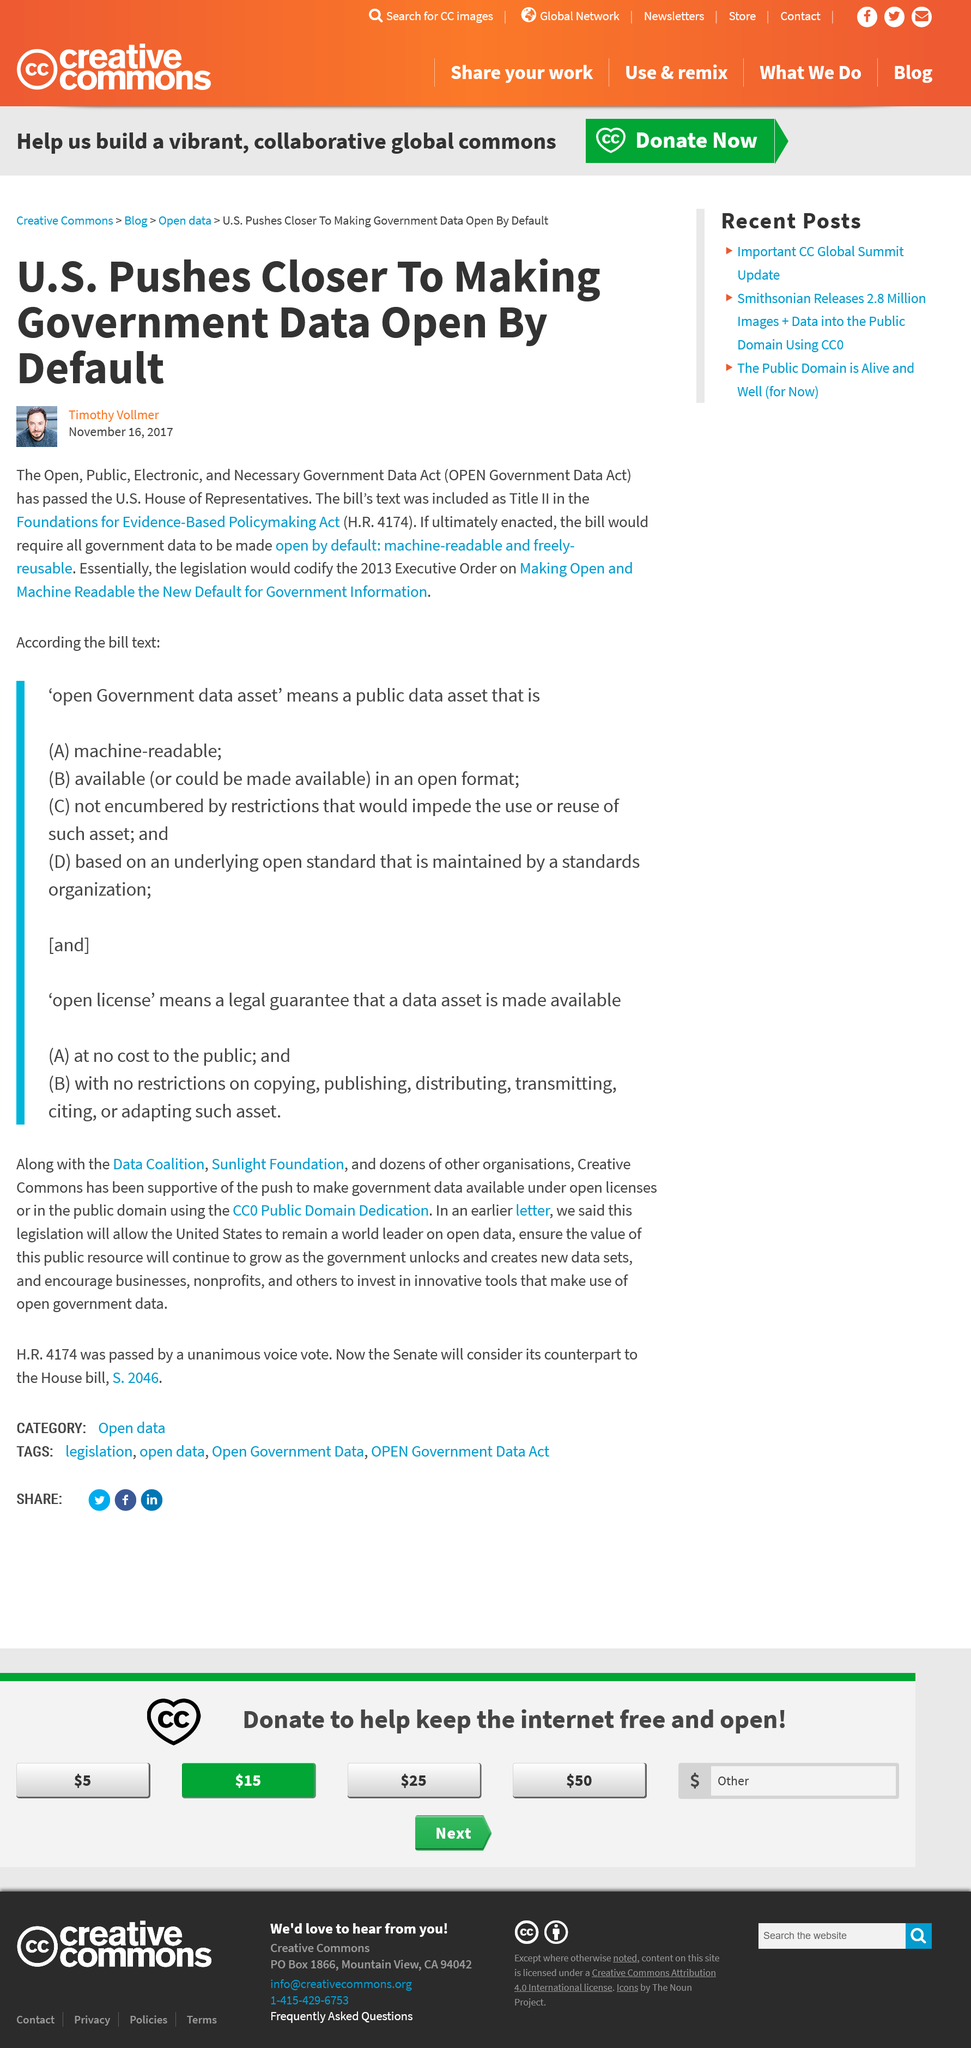Outline some significant characteristics in this image. It is known that the author of this article is Timothy Vollmer. The title of this article is "The United States is moving closer to making government data available by default. This article was written on November 16, 2017, as evidenced by the provided date. 